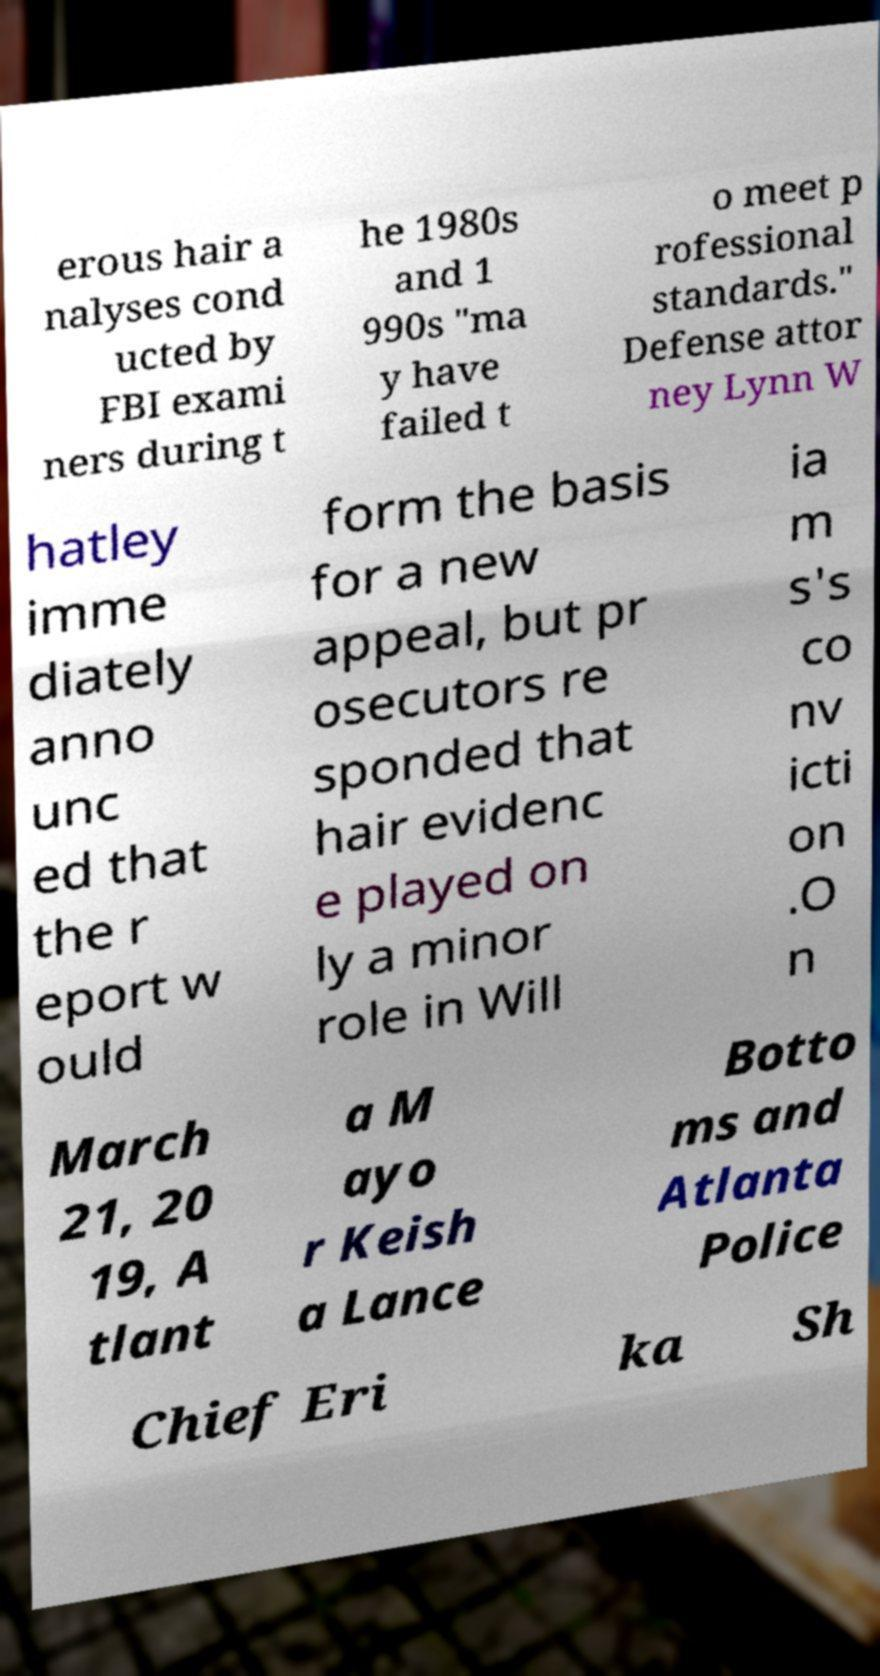Please identify and transcribe the text found in this image. erous hair a nalyses cond ucted by FBI exami ners during t he 1980s and 1 990s "ma y have failed t o meet p rofessional standards." Defense attor ney Lynn W hatley imme diately anno unc ed that the r eport w ould form the basis for a new appeal, but pr osecutors re sponded that hair evidenc e played on ly a minor role in Will ia m s's co nv icti on .O n March 21, 20 19, A tlant a M ayo r Keish a Lance Botto ms and Atlanta Police Chief Eri ka Sh 